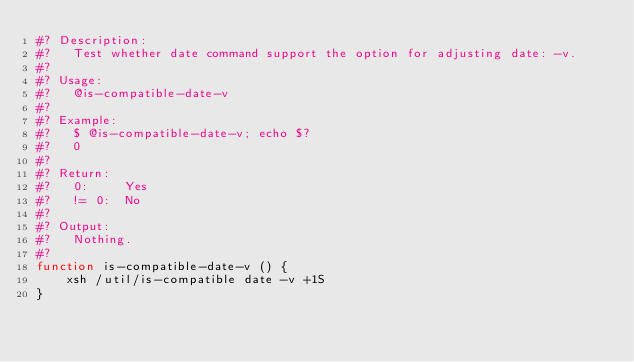Convert code to text. <code><loc_0><loc_0><loc_500><loc_500><_Bash_>#? Description:
#?   Test whether date command support the option for adjusting date: -v.
#?
#? Usage:
#?   @is-compatible-date-v
#?
#? Example:
#?   $ @is-compatible-date-v; echo $?
#?   0
#?
#? Return:
#?   0:     Yes
#?   != 0:  No
#?
#? Output:
#?   Nothing.
#?
function is-compatible-date-v () {
    xsh /util/is-compatible date -v +1S
}
</code> 